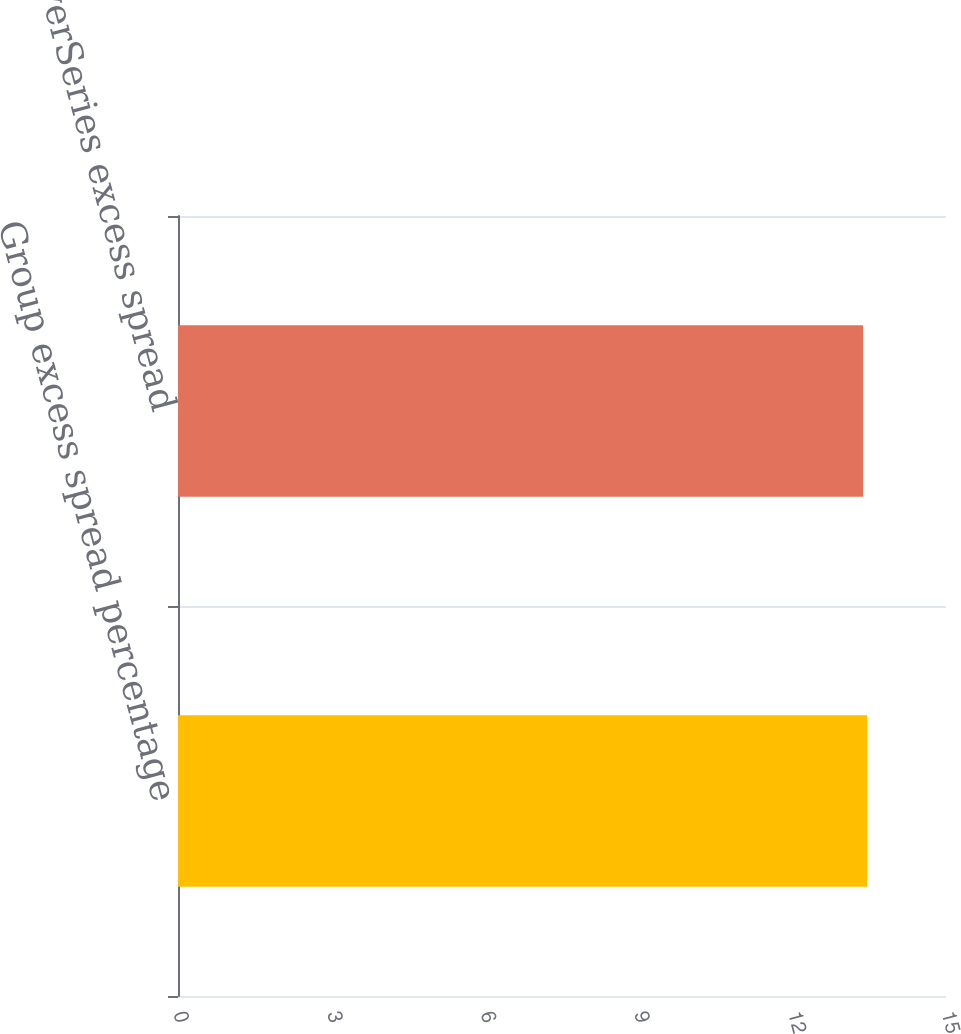Convert chart. <chart><loc_0><loc_0><loc_500><loc_500><bar_chart><fcel>Group excess spread percentage<fcel>DiscoverSeries excess spread<nl><fcel>13.46<fcel>13.38<nl></chart> 